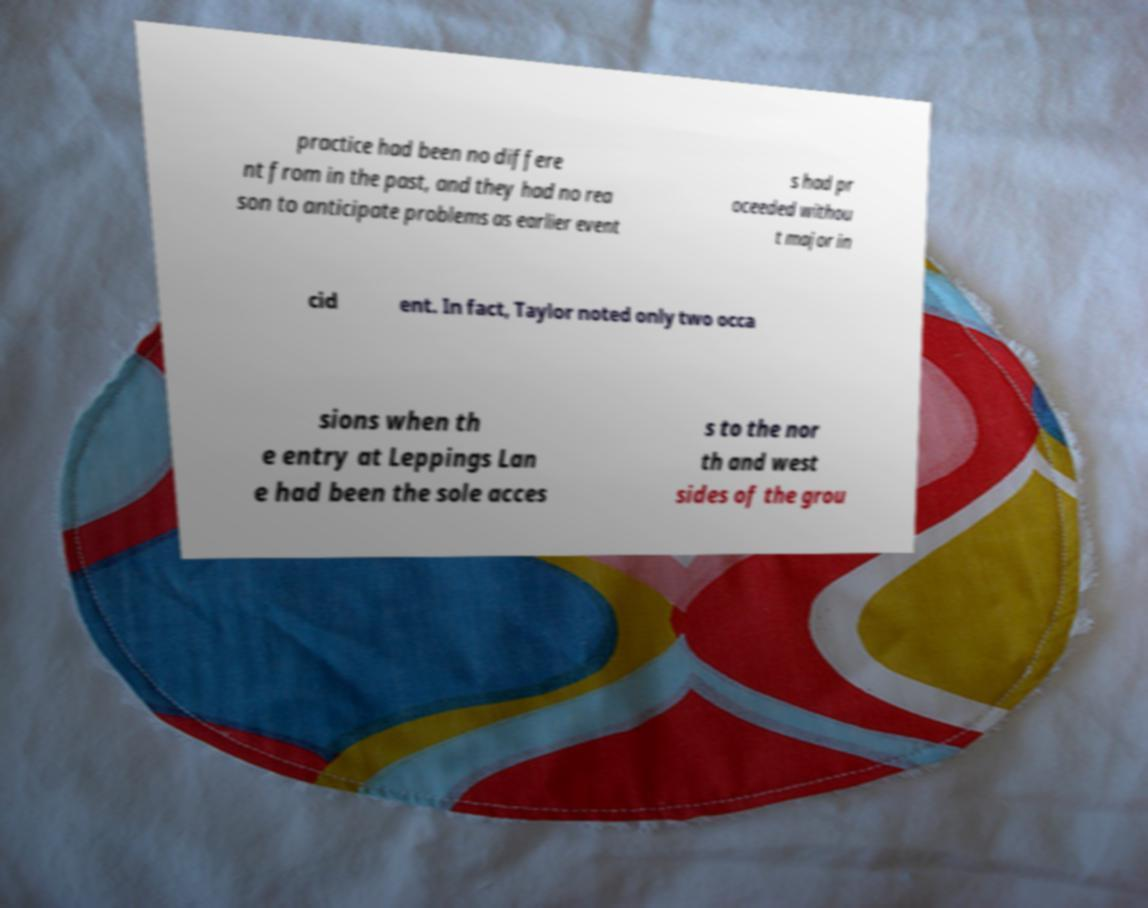What messages or text are displayed in this image? I need them in a readable, typed format. practice had been no differe nt from in the past, and they had no rea son to anticipate problems as earlier event s had pr oceeded withou t major in cid ent. In fact, Taylor noted only two occa sions when th e entry at Leppings Lan e had been the sole acces s to the nor th and west sides of the grou 